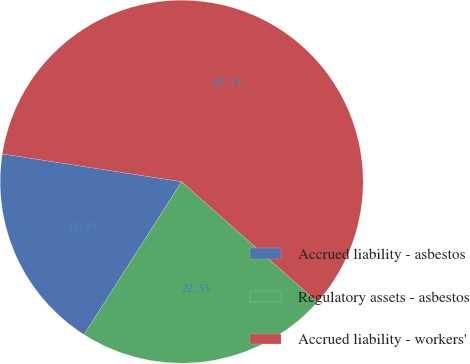Convert chart to OTSL. <chart><loc_0><loc_0><loc_500><loc_500><pie_chart><fcel>Accrued liability - asbestos<fcel>Regulatory assets - asbestos<fcel>Accrued liability - workers'<nl><fcel>18.41%<fcel>22.48%<fcel>59.11%<nl></chart> 